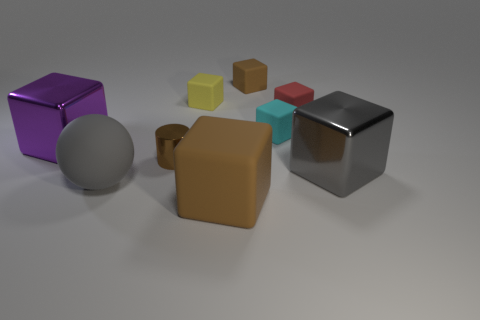Subtract all brown cubes. How many were subtracted if there are1brown cubes left? 1 Subtract 3 blocks. How many blocks are left? 4 Subtract all small yellow matte cubes. How many cubes are left? 6 Subtract all purple blocks. How many blocks are left? 6 Subtract all blue cubes. Subtract all gray cylinders. How many cubes are left? 7 Add 1 tiny green shiny objects. How many objects exist? 10 Subtract all blocks. How many objects are left? 2 Subtract 0 yellow spheres. How many objects are left? 9 Subtract all brown metal cylinders. Subtract all big rubber balls. How many objects are left? 7 Add 3 brown cylinders. How many brown cylinders are left? 4 